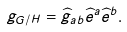Convert formula to latex. <formula><loc_0><loc_0><loc_500><loc_500>g _ { G / H } = \widehat { g } _ { a b } \widehat { e } ^ { a } \widehat { e } ^ { b } .</formula> 